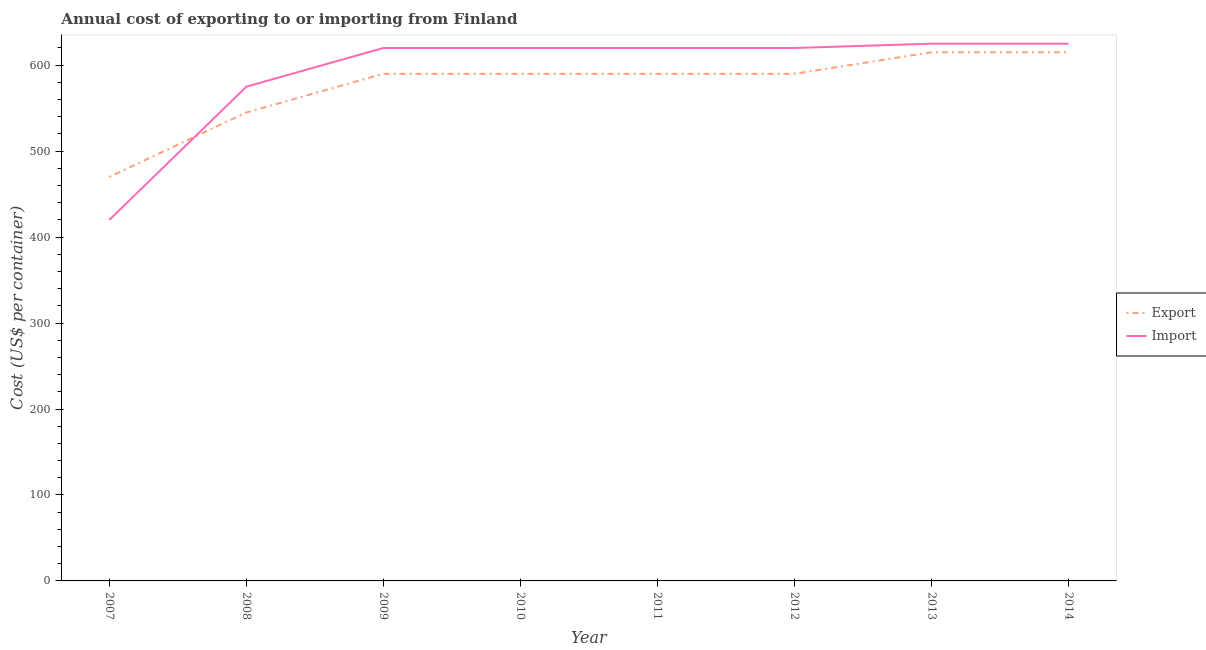What is the export cost in 2007?
Provide a short and direct response. 470. Across all years, what is the maximum import cost?
Ensure brevity in your answer.  625. Across all years, what is the minimum export cost?
Offer a terse response. 470. What is the total import cost in the graph?
Keep it short and to the point. 4725. What is the difference between the export cost in 2008 and the import cost in 2009?
Your answer should be very brief. -75. What is the average import cost per year?
Give a very brief answer. 590.62. In the year 2014, what is the difference between the export cost and import cost?
Your answer should be compact. -10. In how many years, is the import cost greater than 320 US$?
Provide a succinct answer. 8. What is the ratio of the import cost in 2008 to that in 2014?
Your answer should be very brief. 0.92. Is the difference between the import cost in 2010 and 2014 greater than the difference between the export cost in 2010 and 2014?
Offer a very short reply. Yes. What is the difference between the highest and the second highest export cost?
Keep it short and to the point. 0. What is the difference between the highest and the lowest import cost?
Make the answer very short. 205. Is the import cost strictly greater than the export cost over the years?
Give a very brief answer. No. Is the export cost strictly less than the import cost over the years?
Your answer should be compact. No. How are the legend labels stacked?
Keep it short and to the point. Vertical. What is the title of the graph?
Keep it short and to the point. Annual cost of exporting to or importing from Finland. What is the label or title of the Y-axis?
Provide a succinct answer. Cost (US$ per container). What is the Cost (US$ per container) of Export in 2007?
Your answer should be very brief. 470. What is the Cost (US$ per container) in Import in 2007?
Give a very brief answer. 420. What is the Cost (US$ per container) of Export in 2008?
Provide a short and direct response. 545. What is the Cost (US$ per container) of Import in 2008?
Provide a short and direct response. 575. What is the Cost (US$ per container) in Export in 2009?
Provide a succinct answer. 590. What is the Cost (US$ per container) in Import in 2009?
Keep it short and to the point. 620. What is the Cost (US$ per container) of Export in 2010?
Keep it short and to the point. 590. What is the Cost (US$ per container) of Import in 2010?
Provide a succinct answer. 620. What is the Cost (US$ per container) in Export in 2011?
Your answer should be compact. 590. What is the Cost (US$ per container) in Import in 2011?
Keep it short and to the point. 620. What is the Cost (US$ per container) of Export in 2012?
Give a very brief answer. 590. What is the Cost (US$ per container) of Import in 2012?
Your response must be concise. 620. What is the Cost (US$ per container) in Export in 2013?
Provide a short and direct response. 615. What is the Cost (US$ per container) in Import in 2013?
Provide a succinct answer. 625. What is the Cost (US$ per container) of Export in 2014?
Keep it short and to the point. 615. What is the Cost (US$ per container) in Import in 2014?
Offer a very short reply. 625. Across all years, what is the maximum Cost (US$ per container) of Export?
Your response must be concise. 615. Across all years, what is the maximum Cost (US$ per container) in Import?
Ensure brevity in your answer.  625. Across all years, what is the minimum Cost (US$ per container) in Export?
Ensure brevity in your answer.  470. Across all years, what is the minimum Cost (US$ per container) in Import?
Your answer should be very brief. 420. What is the total Cost (US$ per container) of Export in the graph?
Your response must be concise. 4605. What is the total Cost (US$ per container) in Import in the graph?
Your response must be concise. 4725. What is the difference between the Cost (US$ per container) of Export in 2007 and that in 2008?
Your answer should be very brief. -75. What is the difference between the Cost (US$ per container) in Import in 2007 and that in 2008?
Offer a terse response. -155. What is the difference between the Cost (US$ per container) in Export in 2007 and that in 2009?
Offer a very short reply. -120. What is the difference between the Cost (US$ per container) of Import in 2007 and that in 2009?
Ensure brevity in your answer.  -200. What is the difference between the Cost (US$ per container) of Export in 2007 and that in 2010?
Provide a succinct answer. -120. What is the difference between the Cost (US$ per container) of Import in 2007 and that in 2010?
Give a very brief answer. -200. What is the difference between the Cost (US$ per container) in Export in 2007 and that in 2011?
Your answer should be very brief. -120. What is the difference between the Cost (US$ per container) in Import in 2007 and that in 2011?
Your answer should be compact. -200. What is the difference between the Cost (US$ per container) of Export in 2007 and that in 2012?
Your response must be concise. -120. What is the difference between the Cost (US$ per container) in Import in 2007 and that in 2012?
Provide a succinct answer. -200. What is the difference between the Cost (US$ per container) of Export in 2007 and that in 2013?
Give a very brief answer. -145. What is the difference between the Cost (US$ per container) of Import in 2007 and that in 2013?
Keep it short and to the point. -205. What is the difference between the Cost (US$ per container) in Export in 2007 and that in 2014?
Your response must be concise. -145. What is the difference between the Cost (US$ per container) in Import in 2007 and that in 2014?
Your answer should be compact. -205. What is the difference between the Cost (US$ per container) in Export in 2008 and that in 2009?
Offer a very short reply. -45. What is the difference between the Cost (US$ per container) of Import in 2008 and that in 2009?
Your response must be concise. -45. What is the difference between the Cost (US$ per container) in Export in 2008 and that in 2010?
Your response must be concise. -45. What is the difference between the Cost (US$ per container) in Import in 2008 and that in 2010?
Your answer should be compact. -45. What is the difference between the Cost (US$ per container) in Export in 2008 and that in 2011?
Offer a terse response. -45. What is the difference between the Cost (US$ per container) in Import in 2008 and that in 2011?
Make the answer very short. -45. What is the difference between the Cost (US$ per container) of Export in 2008 and that in 2012?
Offer a terse response. -45. What is the difference between the Cost (US$ per container) of Import in 2008 and that in 2012?
Ensure brevity in your answer.  -45. What is the difference between the Cost (US$ per container) in Export in 2008 and that in 2013?
Offer a very short reply. -70. What is the difference between the Cost (US$ per container) of Export in 2008 and that in 2014?
Offer a very short reply. -70. What is the difference between the Cost (US$ per container) in Export in 2009 and that in 2010?
Make the answer very short. 0. What is the difference between the Cost (US$ per container) of Import in 2009 and that in 2011?
Keep it short and to the point. 0. What is the difference between the Cost (US$ per container) of Export in 2009 and that in 2012?
Offer a very short reply. 0. What is the difference between the Cost (US$ per container) of Import in 2009 and that in 2012?
Offer a very short reply. 0. What is the difference between the Cost (US$ per container) in Export in 2009 and that in 2013?
Provide a short and direct response. -25. What is the difference between the Cost (US$ per container) of Export in 2010 and that in 2011?
Provide a succinct answer. 0. What is the difference between the Cost (US$ per container) in Import in 2010 and that in 2011?
Provide a succinct answer. 0. What is the difference between the Cost (US$ per container) of Export in 2010 and that in 2012?
Provide a succinct answer. 0. What is the difference between the Cost (US$ per container) in Import in 2010 and that in 2012?
Your answer should be very brief. 0. What is the difference between the Cost (US$ per container) in Export in 2010 and that in 2013?
Your response must be concise. -25. What is the difference between the Cost (US$ per container) of Export in 2010 and that in 2014?
Offer a terse response. -25. What is the difference between the Cost (US$ per container) of Import in 2011 and that in 2012?
Your response must be concise. 0. What is the difference between the Cost (US$ per container) in Import in 2011 and that in 2013?
Offer a very short reply. -5. What is the difference between the Cost (US$ per container) in Export in 2012 and that in 2013?
Your answer should be very brief. -25. What is the difference between the Cost (US$ per container) of Import in 2012 and that in 2013?
Give a very brief answer. -5. What is the difference between the Cost (US$ per container) of Import in 2012 and that in 2014?
Offer a very short reply. -5. What is the difference between the Cost (US$ per container) of Export in 2007 and the Cost (US$ per container) of Import in 2008?
Your answer should be very brief. -105. What is the difference between the Cost (US$ per container) in Export in 2007 and the Cost (US$ per container) in Import in 2009?
Your response must be concise. -150. What is the difference between the Cost (US$ per container) of Export in 2007 and the Cost (US$ per container) of Import in 2010?
Keep it short and to the point. -150. What is the difference between the Cost (US$ per container) in Export in 2007 and the Cost (US$ per container) in Import in 2011?
Offer a very short reply. -150. What is the difference between the Cost (US$ per container) in Export in 2007 and the Cost (US$ per container) in Import in 2012?
Your response must be concise. -150. What is the difference between the Cost (US$ per container) of Export in 2007 and the Cost (US$ per container) of Import in 2013?
Your response must be concise. -155. What is the difference between the Cost (US$ per container) in Export in 2007 and the Cost (US$ per container) in Import in 2014?
Make the answer very short. -155. What is the difference between the Cost (US$ per container) in Export in 2008 and the Cost (US$ per container) in Import in 2009?
Ensure brevity in your answer.  -75. What is the difference between the Cost (US$ per container) in Export in 2008 and the Cost (US$ per container) in Import in 2010?
Provide a succinct answer. -75. What is the difference between the Cost (US$ per container) in Export in 2008 and the Cost (US$ per container) in Import in 2011?
Make the answer very short. -75. What is the difference between the Cost (US$ per container) in Export in 2008 and the Cost (US$ per container) in Import in 2012?
Your answer should be compact. -75. What is the difference between the Cost (US$ per container) of Export in 2008 and the Cost (US$ per container) of Import in 2013?
Your answer should be very brief. -80. What is the difference between the Cost (US$ per container) in Export in 2008 and the Cost (US$ per container) in Import in 2014?
Your response must be concise. -80. What is the difference between the Cost (US$ per container) of Export in 2009 and the Cost (US$ per container) of Import in 2011?
Your answer should be very brief. -30. What is the difference between the Cost (US$ per container) in Export in 2009 and the Cost (US$ per container) in Import in 2013?
Offer a terse response. -35. What is the difference between the Cost (US$ per container) in Export in 2009 and the Cost (US$ per container) in Import in 2014?
Offer a very short reply. -35. What is the difference between the Cost (US$ per container) of Export in 2010 and the Cost (US$ per container) of Import in 2013?
Keep it short and to the point. -35. What is the difference between the Cost (US$ per container) of Export in 2010 and the Cost (US$ per container) of Import in 2014?
Keep it short and to the point. -35. What is the difference between the Cost (US$ per container) in Export in 2011 and the Cost (US$ per container) in Import in 2013?
Provide a short and direct response. -35. What is the difference between the Cost (US$ per container) in Export in 2011 and the Cost (US$ per container) in Import in 2014?
Ensure brevity in your answer.  -35. What is the difference between the Cost (US$ per container) in Export in 2012 and the Cost (US$ per container) in Import in 2013?
Make the answer very short. -35. What is the difference between the Cost (US$ per container) of Export in 2012 and the Cost (US$ per container) of Import in 2014?
Your response must be concise. -35. What is the difference between the Cost (US$ per container) of Export in 2013 and the Cost (US$ per container) of Import in 2014?
Offer a terse response. -10. What is the average Cost (US$ per container) of Export per year?
Keep it short and to the point. 575.62. What is the average Cost (US$ per container) of Import per year?
Your answer should be compact. 590.62. In the year 2007, what is the difference between the Cost (US$ per container) of Export and Cost (US$ per container) of Import?
Provide a short and direct response. 50. In the year 2008, what is the difference between the Cost (US$ per container) of Export and Cost (US$ per container) of Import?
Offer a terse response. -30. In the year 2010, what is the difference between the Cost (US$ per container) of Export and Cost (US$ per container) of Import?
Give a very brief answer. -30. In the year 2011, what is the difference between the Cost (US$ per container) of Export and Cost (US$ per container) of Import?
Make the answer very short. -30. In the year 2014, what is the difference between the Cost (US$ per container) of Export and Cost (US$ per container) of Import?
Give a very brief answer. -10. What is the ratio of the Cost (US$ per container) in Export in 2007 to that in 2008?
Offer a very short reply. 0.86. What is the ratio of the Cost (US$ per container) of Import in 2007 to that in 2008?
Your answer should be very brief. 0.73. What is the ratio of the Cost (US$ per container) of Export in 2007 to that in 2009?
Your answer should be compact. 0.8. What is the ratio of the Cost (US$ per container) in Import in 2007 to that in 2009?
Offer a very short reply. 0.68. What is the ratio of the Cost (US$ per container) in Export in 2007 to that in 2010?
Provide a short and direct response. 0.8. What is the ratio of the Cost (US$ per container) in Import in 2007 to that in 2010?
Make the answer very short. 0.68. What is the ratio of the Cost (US$ per container) in Export in 2007 to that in 2011?
Your answer should be compact. 0.8. What is the ratio of the Cost (US$ per container) in Import in 2007 to that in 2011?
Keep it short and to the point. 0.68. What is the ratio of the Cost (US$ per container) of Export in 2007 to that in 2012?
Ensure brevity in your answer.  0.8. What is the ratio of the Cost (US$ per container) of Import in 2007 to that in 2012?
Provide a succinct answer. 0.68. What is the ratio of the Cost (US$ per container) of Export in 2007 to that in 2013?
Make the answer very short. 0.76. What is the ratio of the Cost (US$ per container) of Import in 2007 to that in 2013?
Keep it short and to the point. 0.67. What is the ratio of the Cost (US$ per container) of Export in 2007 to that in 2014?
Your answer should be compact. 0.76. What is the ratio of the Cost (US$ per container) in Import in 2007 to that in 2014?
Your response must be concise. 0.67. What is the ratio of the Cost (US$ per container) in Export in 2008 to that in 2009?
Provide a short and direct response. 0.92. What is the ratio of the Cost (US$ per container) in Import in 2008 to that in 2009?
Offer a very short reply. 0.93. What is the ratio of the Cost (US$ per container) of Export in 2008 to that in 2010?
Provide a short and direct response. 0.92. What is the ratio of the Cost (US$ per container) in Import in 2008 to that in 2010?
Provide a short and direct response. 0.93. What is the ratio of the Cost (US$ per container) of Export in 2008 to that in 2011?
Offer a very short reply. 0.92. What is the ratio of the Cost (US$ per container) in Import in 2008 to that in 2011?
Give a very brief answer. 0.93. What is the ratio of the Cost (US$ per container) of Export in 2008 to that in 2012?
Provide a succinct answer. 0.92. What is the ratio of the Cost (US$ per container) of Import in 2008 to that in 2012?
Make the answer very short. 0.93. What is the ratio of the Cost (US$ per container) in Export in 2008 to that in 2013?
Your answer should be very brief. 0.89. What is the ratio of the Cost (US$ per container) of Export in 2008 to that in 2014?
Offer a terse response. 0.89. What is the ratio of the Cost (US$ per container) in Import in 2008 to that in 2014?
Your answer should be very brief. 0.92. What is the ratio of the Cost (US$ per container) in Export in 2009 to that in 2010?
Provide a short and direct response. 1. What is the ratio of the Cost (US$ per container) of Export in 2009 to that in 2011?
Keep it short and to the point. 1. What is the ratio of the Cost (US$ per container) in Import in 2009 to that in 2011?
Provide a short and direct response. 1. What is the ratio of the Cost (US$ per container) of Import in 2009 to that in 2012?
Make the answer very short. 1. What is the ratio of the Cost (US$ per container) in Export in 2009 to that in 2013?
Offer a terse response. 0.96. What is the ratio of the Cost (US$ per container) in Import in 2009 to that in 2013?
Your response must be concise. 0.99. What is the ratio of the Cost (US$ per container) of Export in 2009 to that in 2014?
Your answer should be very brief. 0.96. What is the ratio of the Cost (US$ per container) in Import in 2009 to that in 2014?
Provide a short and direct response. 0.99. What is the ratio of the Cost (US$ per container) in Export in 2010 to that in 2011?
Your answer should be compact. 1. What is the ratio of the Cost (US$ per container) of Import in 2010 to that in 2012?
Make the answer very short. 1. What is the ratio of the Cost (US$ per container) in Export in 2010 to that in 2013?
Provide a short and direct response. 0.96. What is the ratio of the Cost (US$ per container) in Export in 2010 to that in 2014?
Provide a succinct answer. 0.96. What is the ratio of the Cost (US$ per container) in Import in 2011 to that in 2012?
Offer a terse response. 1. What is the ratio of the Cost (US$ per container) of Export in 2011 to that in 2013?
Give a very brief answer. 0.96. What is the ratio of the Cost (US$ per container) of Import in 2011 to that in 2013?
Make the answer very short. 0.99. What is the ratio of the Cost (US$ per container) in Export in 2011 to that in 2014?
Your answer should be compact. 0.96. What is the ratio of the Cost (US$ per container) in Export in 2012 to that in 2013?
Keep it short and to the point. 0.96. What is the ratio of the Cost (US$ per container) of Export in 2012 to that in 2014?
Offer a very short reply. 0.96. What is the ratio of the Cost (US$ per container) of Import in 2012 to that in 2014?
Ensure brevity in your answer.  0.99. What is the ratio of the Cost (US$ per container) of Export in 2013 to that in 2014?
Your answer should be compact. 1. What is the difference between the highest and the second highest Cost (US$ per container) in Export?
Offer a terse response. 0. What is the difference between the highest and the second highest Cost (US$ per container) of Import?
Your answer should be compact. 0. What is the difference between the highest and the lowest Cost (US$ per container) of Export?
Offer a very short reply. 145. What is the difference between the highest and the lowest Cost (US$ per container) of Import?
Offer a terse response. 205. 